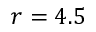Convert formula to latex. <formula><loc_0><loc_0><loc_500><loc_500>r = 4 . 5</formula> 